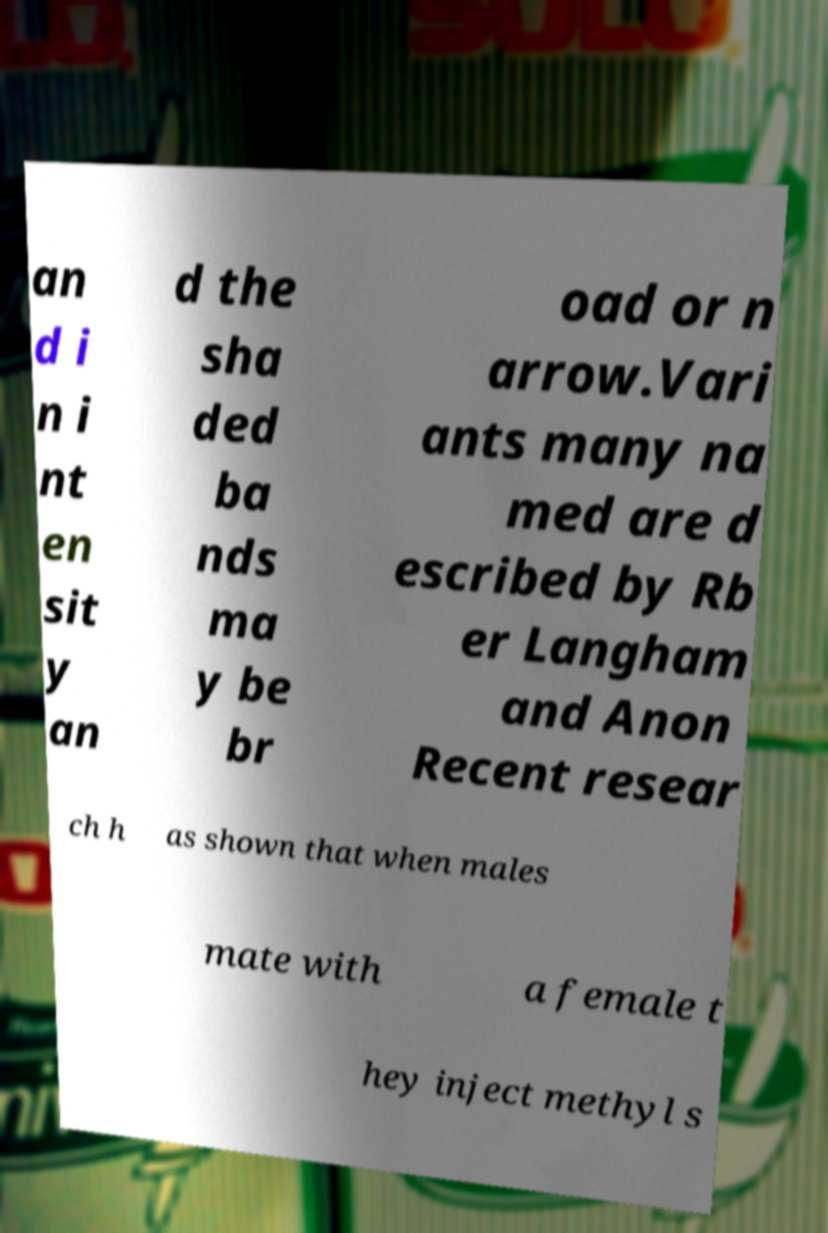What messages or text are displayed in this image? I need them in a readable, typed format. an d i n i nt en sit y an d the sha ded ba nds ma y be br oad or n arrow.Vari ants many na med are d escribed by Rb er Langham and Anon Recent resear ch h as shown that when males mate with a female t hey inject methyl s 